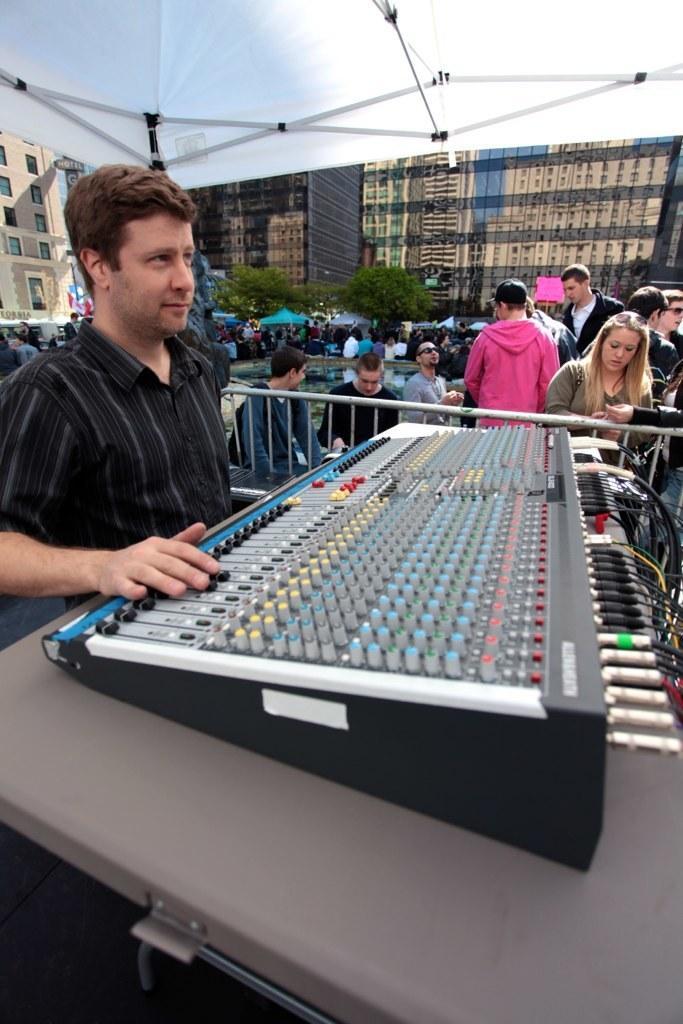Can you describe this image briefly? On the left side of the image, we can see a man is operating a device. This device is placed on the table. On the left side bottom of the image, we can see the path. Background there are so many people, trees, buildings and tent. 